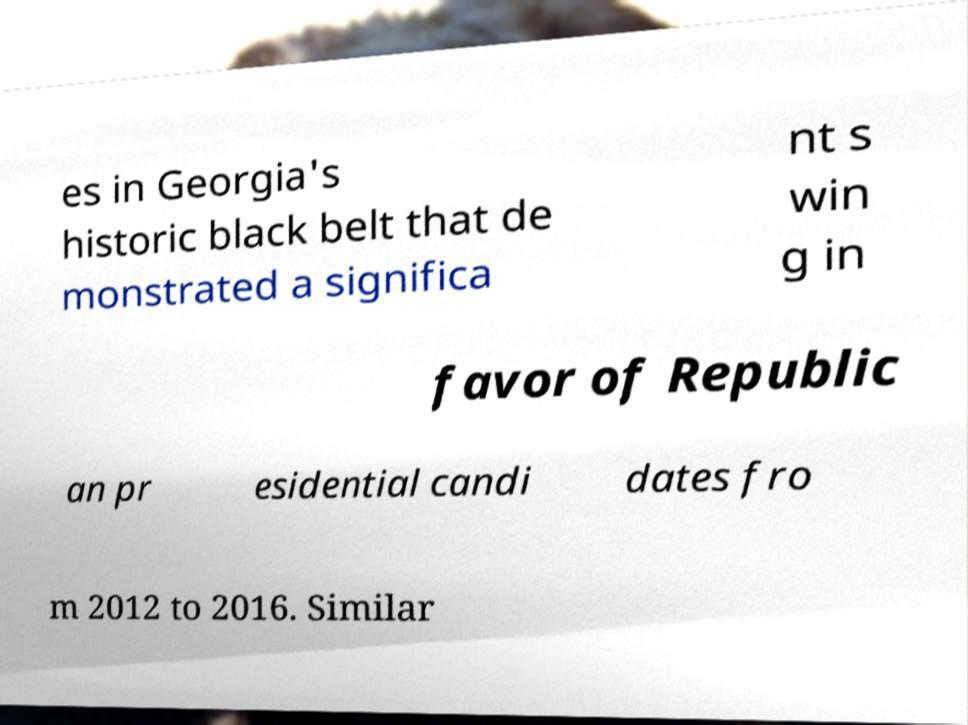Please read and relay the text visible in this image. What does it say? es in Georgia's historic black belt that de monstrated a significa nt s win g in favor of Republic an pr esidential candi dates fro m 2012 to 2016. Similar 